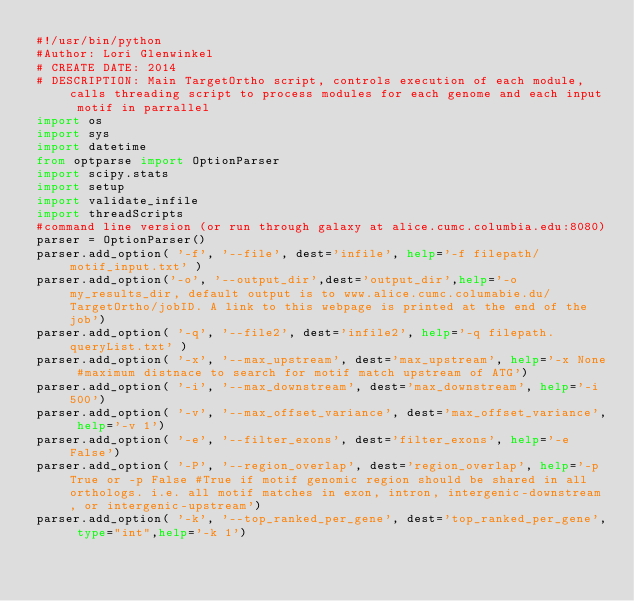Convert code to text. <code><loc_0><loc_0><loc_500><loc_500><_Python_>#!/usr/bin/python
#Author: Lori Glenwinkel
# CREATE DATE: 2014
# DESCRIPTION: Main TargetOrtho script, controls execution of each module, calls threading script to process modules for each genome and each input motif in parrallel
import os
import sys
import datetime
from optparse import OptionParser
import scipy.stats
import setup
import validate_infile
import threadScripts
#command line version (or run through galaxy at alice.cumc.columbia.edu:8080)    
parser = OptionParser()
parser.add_option( '-f', '--file', dest='infile', help='-f filepath/motif_input.txt' )
parser.add_option('-o', '--output_dir',dest='output_dir',help='-o my_results_dir, default output is to www.alice.cumc.columabie.du/TargetOrtho/jobID. A link to this webpage is printed at the end of the job')
parser.add_option( '-q', '--file2', dest='infile2', help='-q filepath.queryList.txt' )
parser.add_option( '-x', '--max_upstream', dest='max_upstream', help='-x None #maximum distnace to search for motif match upstream of ATG')
parser.add_option( '-i', '--max_downstream', dest='max_downstream', help='-i 500')
parser.add_option( '-v', '--max_offset_variance', dest='max_offset_variance', help='-v 1')
parser.add_option( '-e', '--filter_exons', dest='filter_exons', help='-e False')
parser.add_option( '-P', '--region_overlap', dest='region_overlap', help='-p True or -p False #True if motif genomic region should be shared in all orthologs. i.e. all motif matches in exon, intron, intergenic-downstream, or intergenic-upstream')
parser.add_option( '-k', '--top_ranked_per_gene', dest='top_ranked_per_gene', type="int",help='-k 1')</code> 